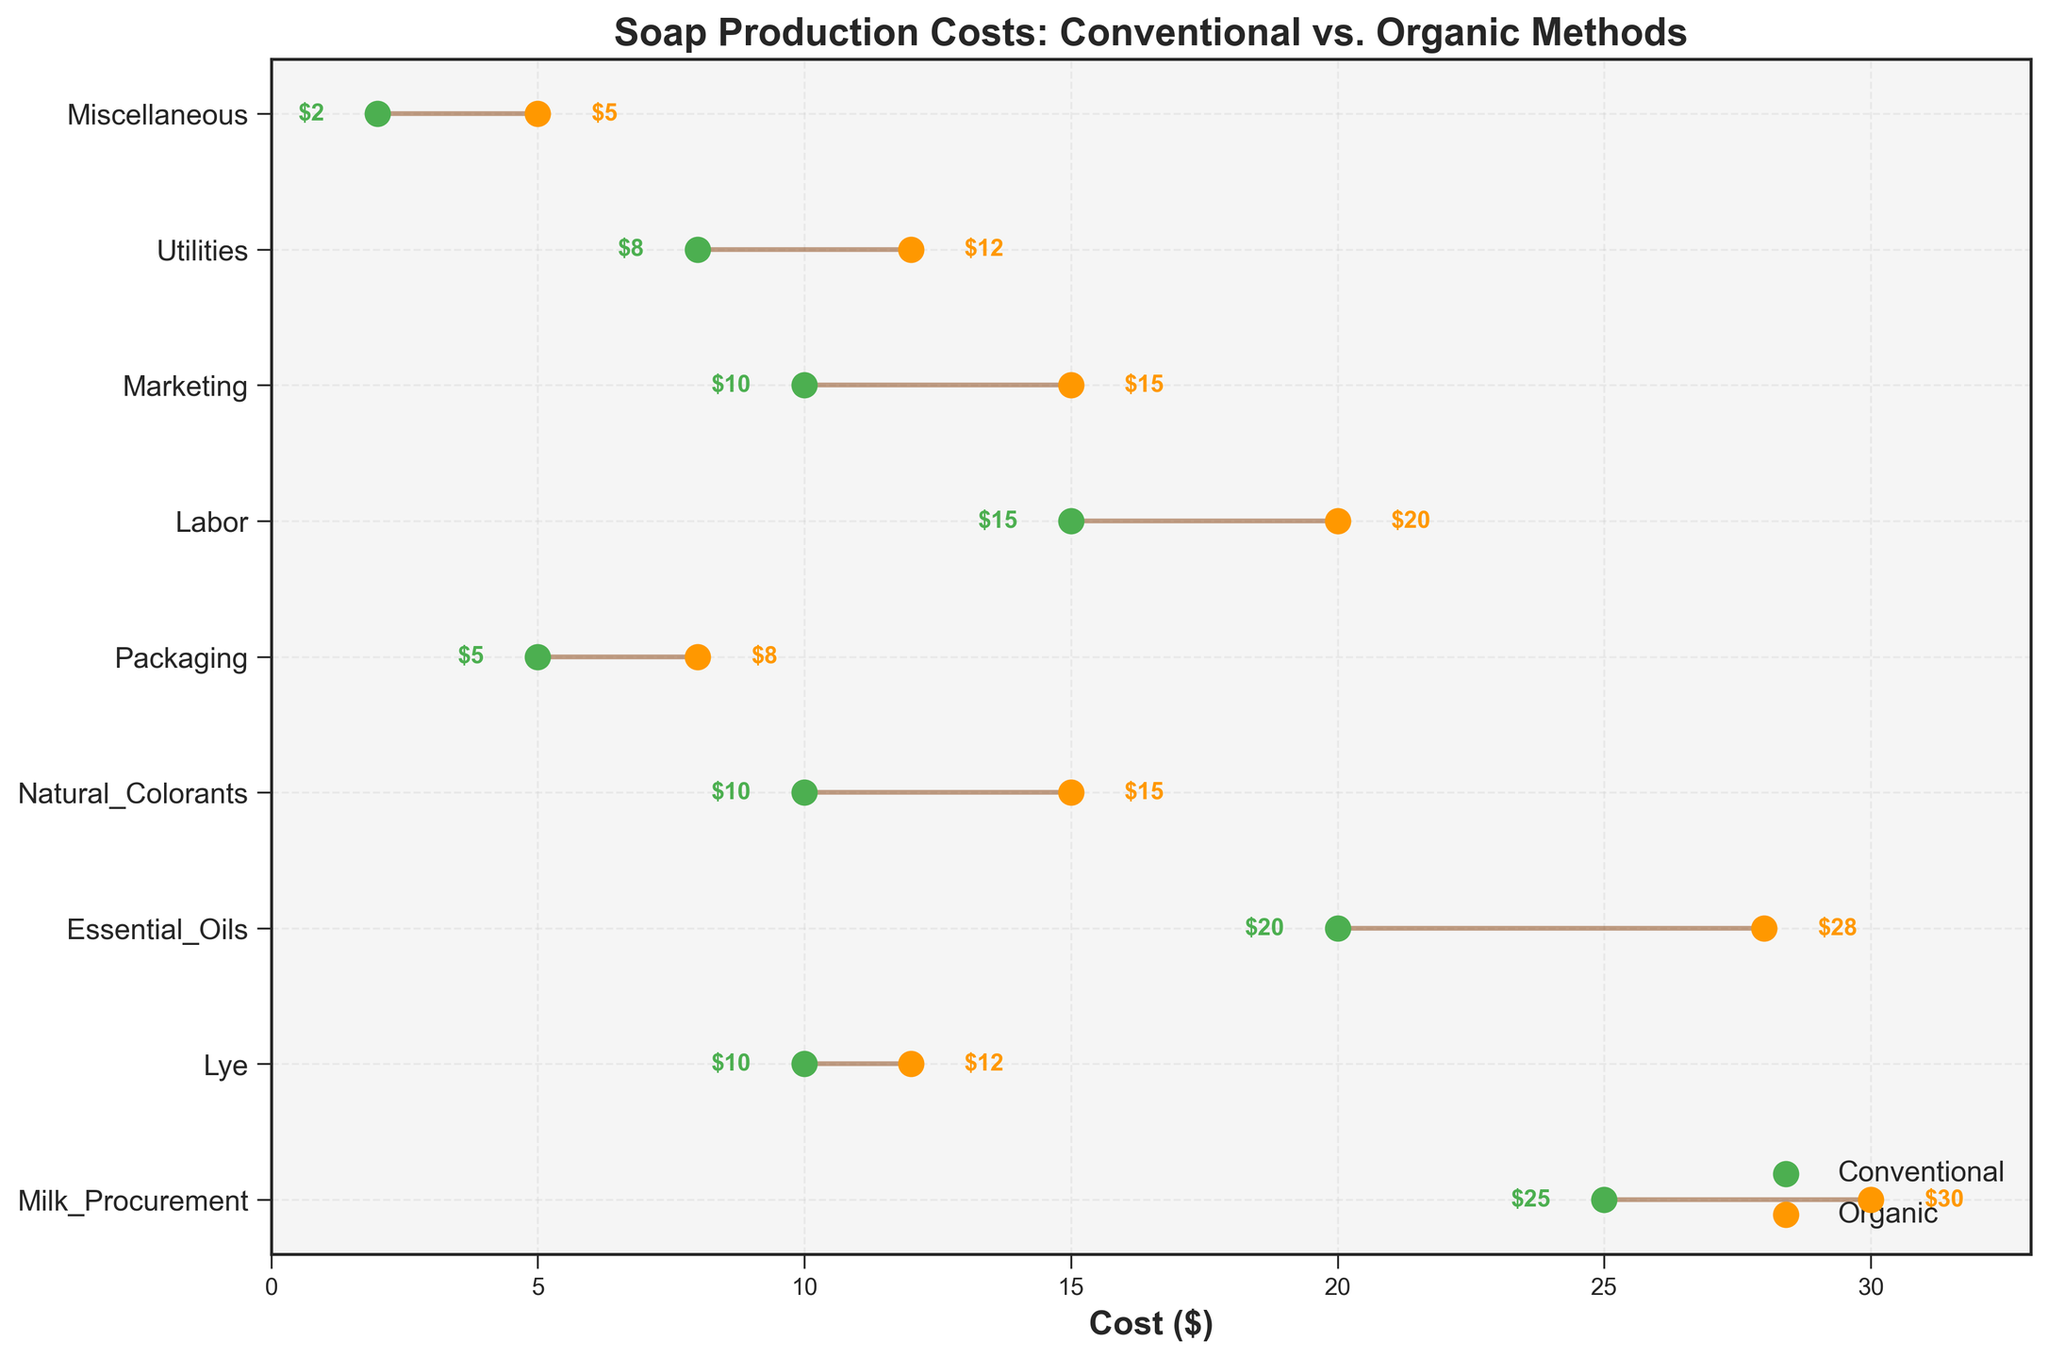What is the title of the plot? Look at the top center of the plot where the title is usually located. The title is written in bold and is larger than most other text on the plot.
Answer: Soap Production Costs: Conventional vs. Organic Methods What category has the smallest cost difference between conventional and organic methods? Analyze the length of the lines between conventional and organic costs. The shortest line indicates the smallest difference.
Answer: Lye Which cost category has the largest cost increase when switching from conventional to organic methods? Compare the lengths of the lines between conventional and organic costs. The longest line will indicate the largest increase.
Answer: Essential Oils How much more does it cost for packaging in organic methods compared to conventional methods? Locate the Packaging category and read the conventional and organic cost values. Subtract the conventional cost from the organic cost.
Answer: $3 more (Organic: $8, Conventional: $5) Which method has higher labor costs, and by how much? Compare the labor costs between conventional and organic methods by looking at their respective points. Subtract the conventional cost from the organic cost.
Answer: Organic, $5 more What is the total cost for conventional methods? Add up all the conventional cost values from each category. Calculation: 25 + 10 + 20 + 10 + 5 + 15 + 10 + 8 + 2 = 105
Answer: $105 What is the total cost for organic methods? Add up all the organic cost values from each category. Calculation: 30 + 12 + 28 + 15 + 8 + 20 + 15 + 12 + 5 = 145
Answer: $145 How much does the essential oils category cost in the conventional method? Read the conventional cost value corresponding to the Essential Oils category from the plot.
Answer: $20 Which category has the highest cost in both conventional and organic methods? Identify the categories with the highest values among both conventional and organic costs. Compare the maximum values in each method.
Answer: Milk Procurement (highest conventional), Essential Oils (highest organic) What is the average cost for both methods combined in the Marketing category? Add the conventional and organic costs for Marketing and divide by 2. Calculation: (10 + 15) / 2 = 12.5
Answer: $12.50 